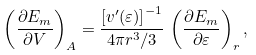<formula> <loc_0><loc_0><loc_500><loc_500>\left ( \frac { \partial E _ { m } } { \partial V } \right ) _ { A } = \frac { \left [ v ^ { \prime } ( \varepsilon ) \right ] ^ { - 1 } } { 4 \pi r ^ { 3 } / 3 } \, \left ( \frac { \partial E _ { m } } { \partial \varepsilon } \right ) _ { r } ,</formula> 